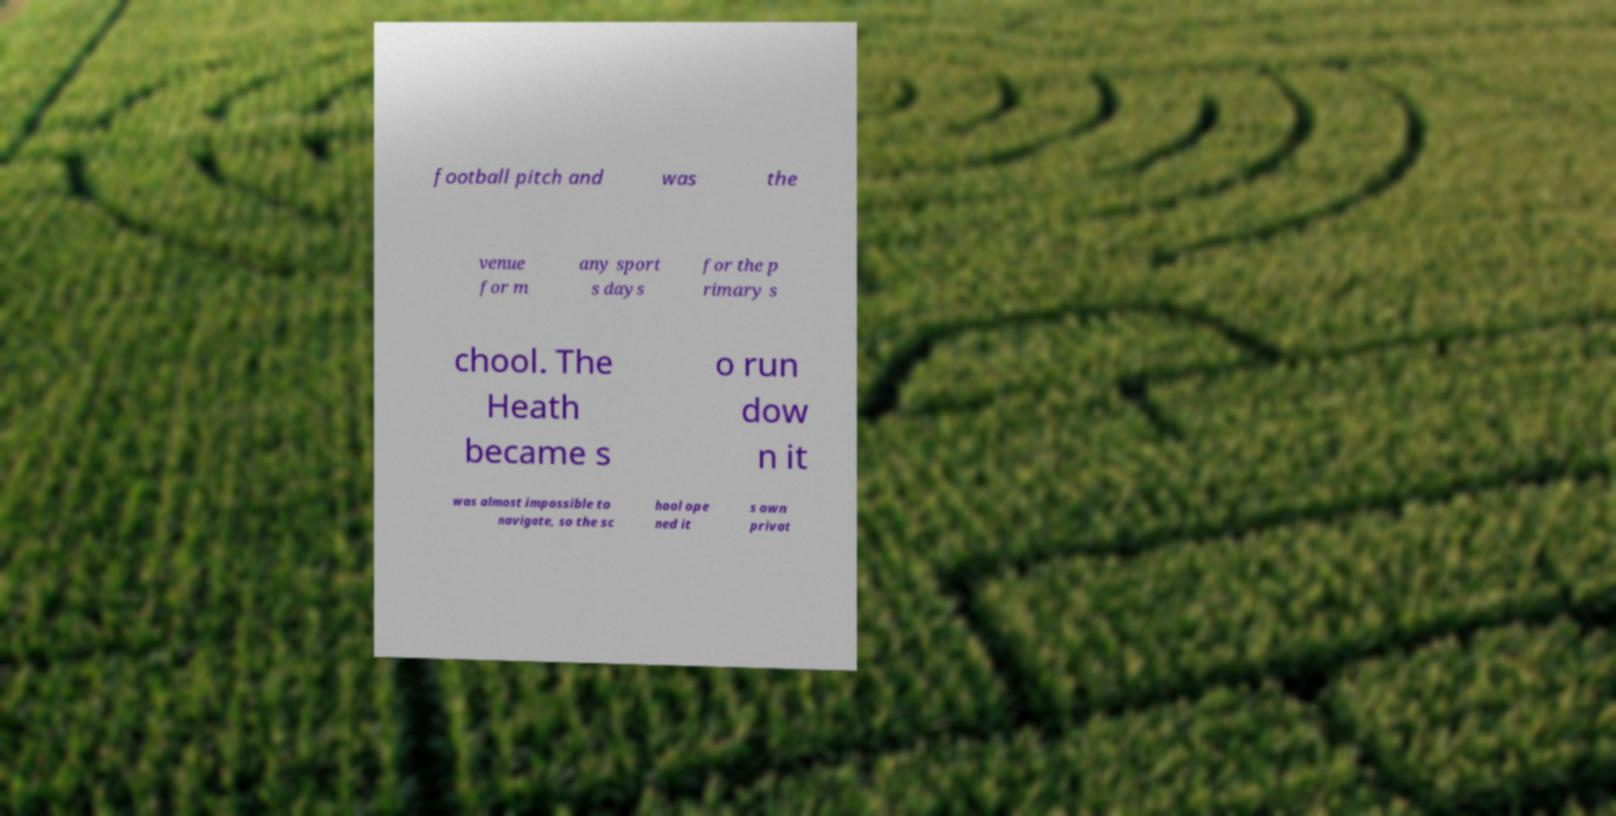Please identify and transcribe the text found in this image. football pitch and was the venue for m any sport s days for the p rimary s chool. The Heath became s o run dow n it was almost impossible to navigate, so the sc hool ope ned it s own privat 